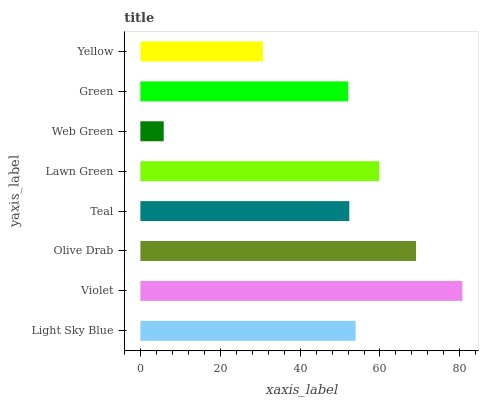Is Web Green the minimum?
Answer yes or no. Yes. Is Violet the maximum?
Answer yes or no. Yes. Is Olive Drab the minimum?
Answer yes or no. No. Is Olive Drab the maximum?
Answer yes or no. No. Is Violet greater than Olive Drab?
Answer yes or no. Yes. Is Olive Drab less than Violet?
Answer yes or no. Yes. Is Olive Drab greater than Violet?
Answer yes or no. No. Is Violet less than Olive Drab?
Answer yes or no. No. Is Light Sky Blue the high median?
Answer yes or no. Yes. Is Teal the low median?
Answer yes or no. Yes. Is Teal the high median?
Answer yes or no. No. Is Lawn Green the low median?
Answer yes or no. No. 